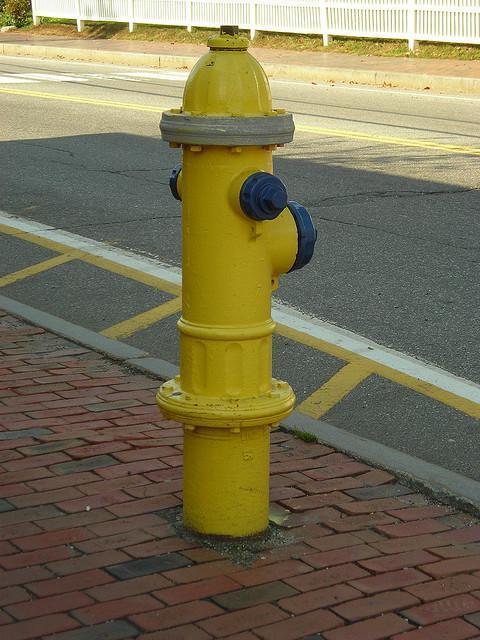How many trees are potted across the street?
Give a very brief answer. 0. How many people are wearing red gloves?
Give a very brief answer. 0. 